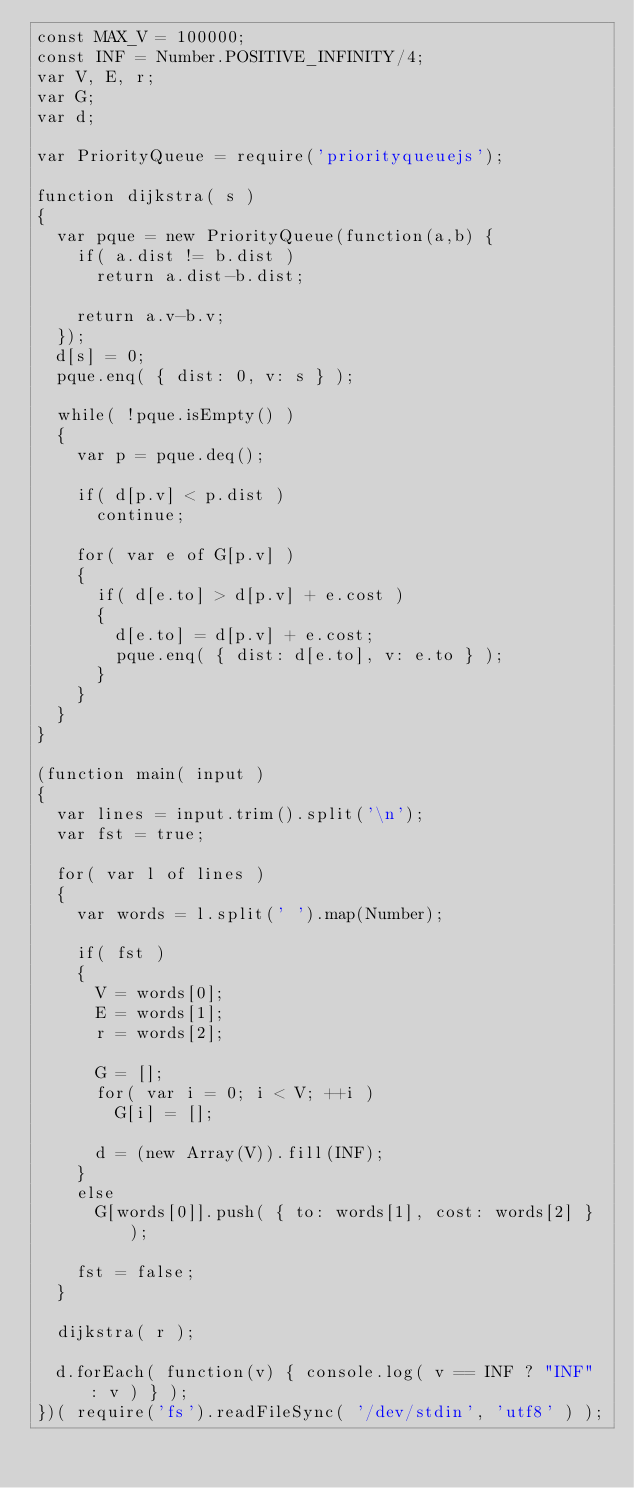<code> <loc_0><loc_0><loc_500><loc_500><_JavaScript_>const MAX_V = 100000;
const INF = Number.POSITIVE_INFINITY/4;
var V, E, r;
var G;
var d;

var PriorityQueue = require('priorityqueuejs');

function dijkstra( s )
{
  var pque = new PriorityQueue(function(a,b) { 
    if( a.dist != b.dist )
      return a.dist-b.dist;

    return a.v-b.v;
  });
  d[s] = 0;
  pque.enq( { dist: 0, v: s } );

  while( !pque.isEmpty() )
  {
    var p = pque.deq();
    
    if( d[p.v] < p.dist )
      continue;

    for( var e of G[p.v] )
    {
      if( d[e.to] > d[p.v] + e.cost )
      {
        d[e.to] = d[p.v] + e.cost;
        pque.enq( { dist: d[e.to], v: e.to } );
      }
    }
  }
}

(function main( input )
{
  var lines = input.trim().split('\n');
  var fst = true;

  for( var l of lines )
  {
    var words = l.split(' ').map(Number);

    if( fst )
    {
      V = words[0];
      E = words[1];
      r = words[2];

      G = [];
      for( var i = 0; i < V; ++i )
        G[i] = [];

      d = (new Array(V)).fill(INF);
    }
    else
      G[words[0]].push( { to: words[1], cost: words[2] } );

    fst = false;
  }

  dijkstra( r );

  d.forEach( function(v) { console.log( v == INF ? "INF" : v ) } );
})( require('fs').readFileSync( '/dev/stdin', 'utf8' ) );</code> 